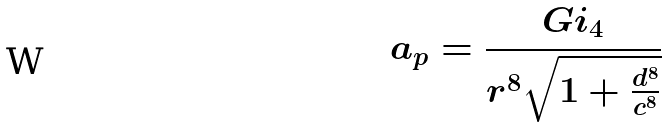<formula> <loc_0><loc_0><loc_500><loc_500>a _ { p } = \frac { G i _ { 4 } } { r ^ { 8 } \sqrt { 1 + \frac { d ^ { 8 } } { c ^ { 8 } } } }</formula> 